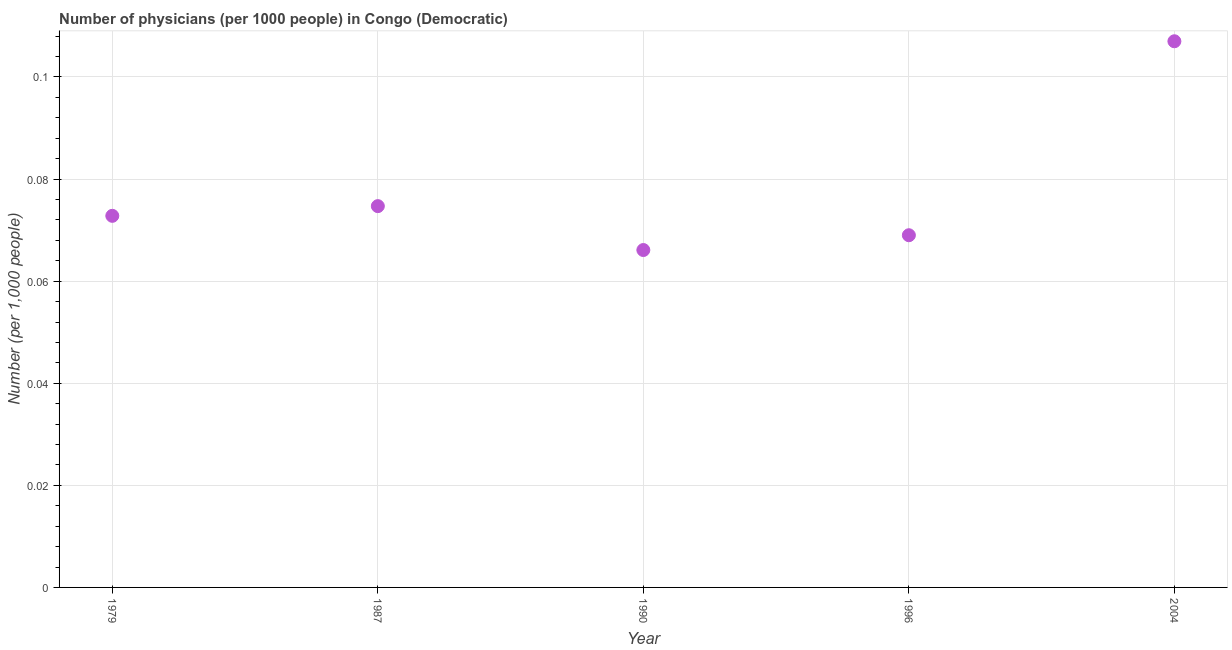What is the number of physicians in 2004?
Offer a terse response. 0.11. Across all years, what is the maximum number of physicians?
Provide a short and direct response. 0.11. Across all years, what is the minimum number of physicians?
Your answer should be compact. 0.07. In which year was the number of physicians maximum?
Your answer should be compact. 2004. What is the sum of the number of physicians?
Offer a terse response. 0.39. What is the difference between the number of physicians in 1990 and 2004?
Keep it short and to the point. -0.04. What is the average number of physicians per year?
Keep it short and to the point. 0.08. What is the median number of physicians?
Keep it short and to the point. 0.07. In how many years, is the number of physicians greater than 0.064 ?
Offer a very short reply. 5. Do a majority of the years between 1996 and 1979 (inclusive) have number of physicians greater than 0.02 ?
Your answer should be compact. Yes. What is the ratio of the number of physicians in 1979 to that in 1990?
Ensure brevity in your answer.  1.1. Is the number of physicians in 1990 less than that in 1996?
Ensure brevity in your answer.  Yes. Is the difference between the number of physicians in 1979 and 2004 greater than the difference between any two years?
Offer a very short reply. No. What is the difference between the highest and the second highest number of physicians?
Your answer should be compact. 0.03. Is the sum of the number of physicians in 1987 and 2004 greater than the maximum number of physicians across all years?
Offer a terse response. Yes. What is the difference between the highest and the lowest number of physicians?
Provide a short and direct response. 0.04. In how many years, is the number of physicians greater than the average number of physicians taken over all years?
Give a very brief answer. 1. How many years are there in the graph?
Ensure brevity in your answer.  5. Does the graph contain any zero values?
Keep it short and to the point. No. Does the graph contain grids?
Offer a very short reply. Yes. What is the title of the graph?
Keep it short and to the point. Number of physicians (per 1000 people) in Congo (Democratic). What is the label or title of the X-axis?
Provide a short and direct response. Year. What is the label or title of the Y-axis?
Keep it short and to the point. Number (per 1,0 people). What is the Number (per 1,000 people) in 1979?
Give a very brief answer. 0.07. What is the Number (per 1,000 people) in 1987?
Make the answer very short. 0.07. What is the Number (per 1,000 people) in 1990?
Make the answer very short. 0.07. What is the Number (per 1,000 people) in 1996?
Your answer should be compact. 0.07. What is the Number (per 1,000 people) in 2004?
Offer a terse response. 0.11. What is the difference between the Number (per 1,000 people) in 1979 and 1987?
Offer a terse response. -0. What is the difference between the Number (per 1,000 people) in 1979 and 1990?
Give a very brief answer. 0.01. What is the difference between the Number (per 1,000 people) in 1979 and 1996?
Offer a terse response. 0. What is the difference between the Number (per 1,000 people) in 1979 and 2004?
Keep it short and to the point. -0.03. What is the difference between the Number (per 1,000 people) in 1987 and 1990?
Give a very brief answer. 0.01. What is the difference between the Number (per 1,000 people) in 1987 and 1996?
Your answer should be very brief. 0.01. What is the difference between the Number (per 1,000 people) in 1987 and 2004?
Your answer should be compact. -0.03. What is the difference between the Number (per 1,000 people) in 1990 and 1996?
Keep it short and to the point. -0. What is the difference between the Number (per 1,000 people) in 1990 and 2004?
Your answer should be very brief. -0.04. What is the difference between the Number (per 1,000 people) in 1996 and 2004?
Give a very brief answer. -0.04. What is the ratio of the Number (per 1,000 people) in 1979 to that in 1987?
Your answer should be compact. 0.97. What is the ratio of the Number (per 1,000 people) in 1979 to that in 1990?
Make the answer very short. 1.1. What is the ratio of the Number (per 1,000 people) in 1979 to that in 1996?
Offer a terse response. 1.05. What is the ratio of the Number (per 1,000 people) in 1979 to that in 2004?
Provide a short and direct response. 0.68. What is the ratio of the Number (per 1,000 people) in 1987 to that in 1990?
Provide a succinct answer. 1.13. What is the ratio of the Number (per 1,000 people) in 1987 to that in 1996?
Your response must be concise. 1.08. What is the ratio of the Number (per 1,000 people) in 1987 to that in 2004?
Ensure brevity in your answer.  0.7. What is the ratio of the Number (per 1,000 people) in 1990 to that in 1996?
Ensure brevity in your answer.  0.96. What is the ratio of the Number (per 1,000 people) in 1990 to that in 2004?
Your response must be concise. 0.62. What is the ratio of the Number (per 1,000 people) in 1996 to that in 2004?
Provide a succinct answer. 0.65. 